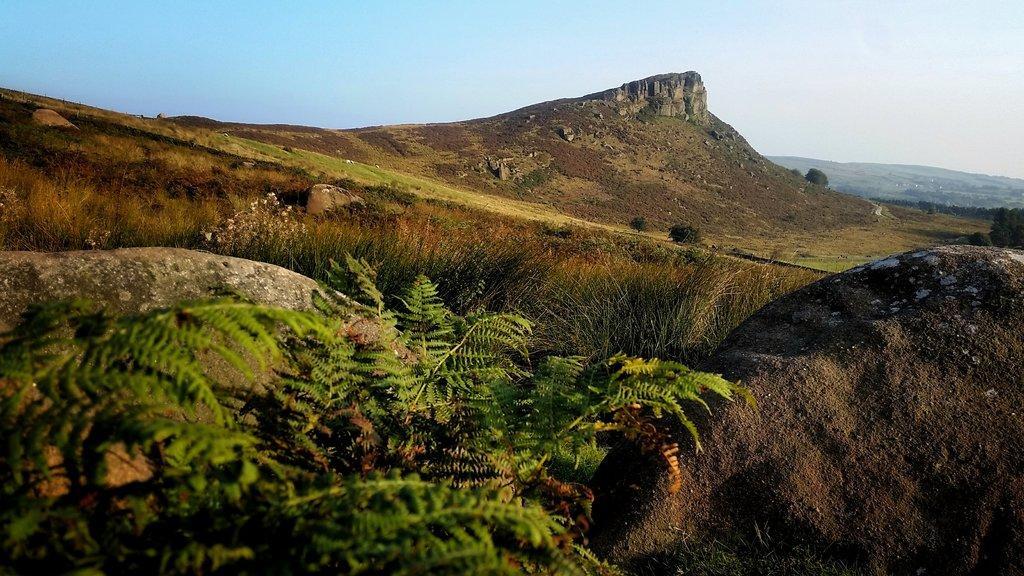How would you summarize this image in a sentence or two? In the left side there are trees, in the right side it is a rock, in the middle it looks like a rocky hill. At the top it's a sunny sky. 